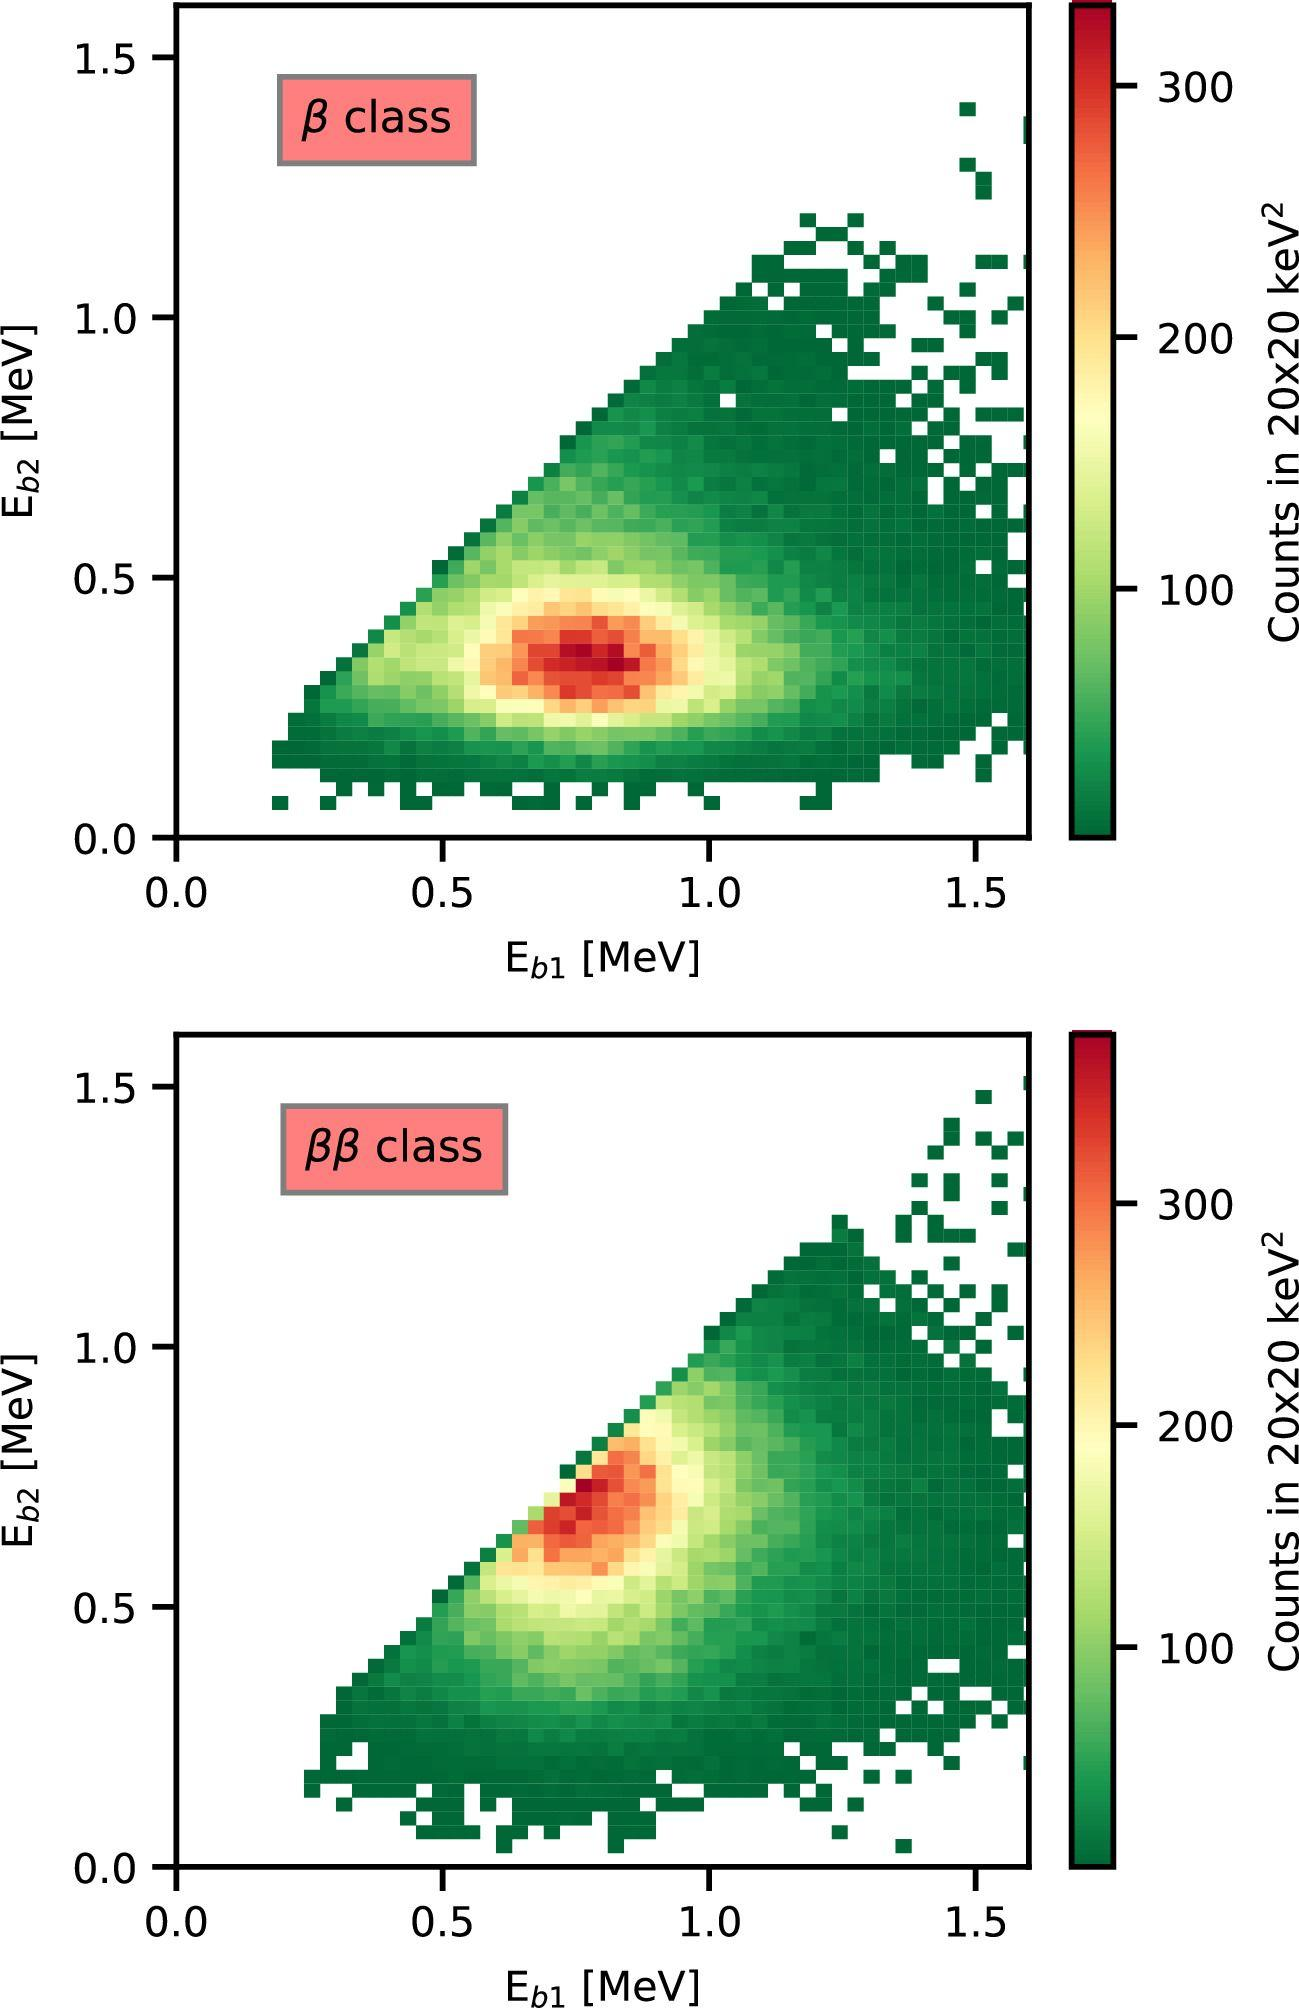Can you explain what the colors represent in these plots? Certainly! In the plots, the colors correspond to the number of counts, or observations, of specific events where two energy measurements—E_b1 and E_b2—were taken simultaneously. The color bar on the right indicates the scale, with darker greens representing fewer counts and warmer colors like yellows and reds signifying higher counts. This type of color-coded heat map allows us to quickly assess where the majority of events lie and the correlation between the two variables. 